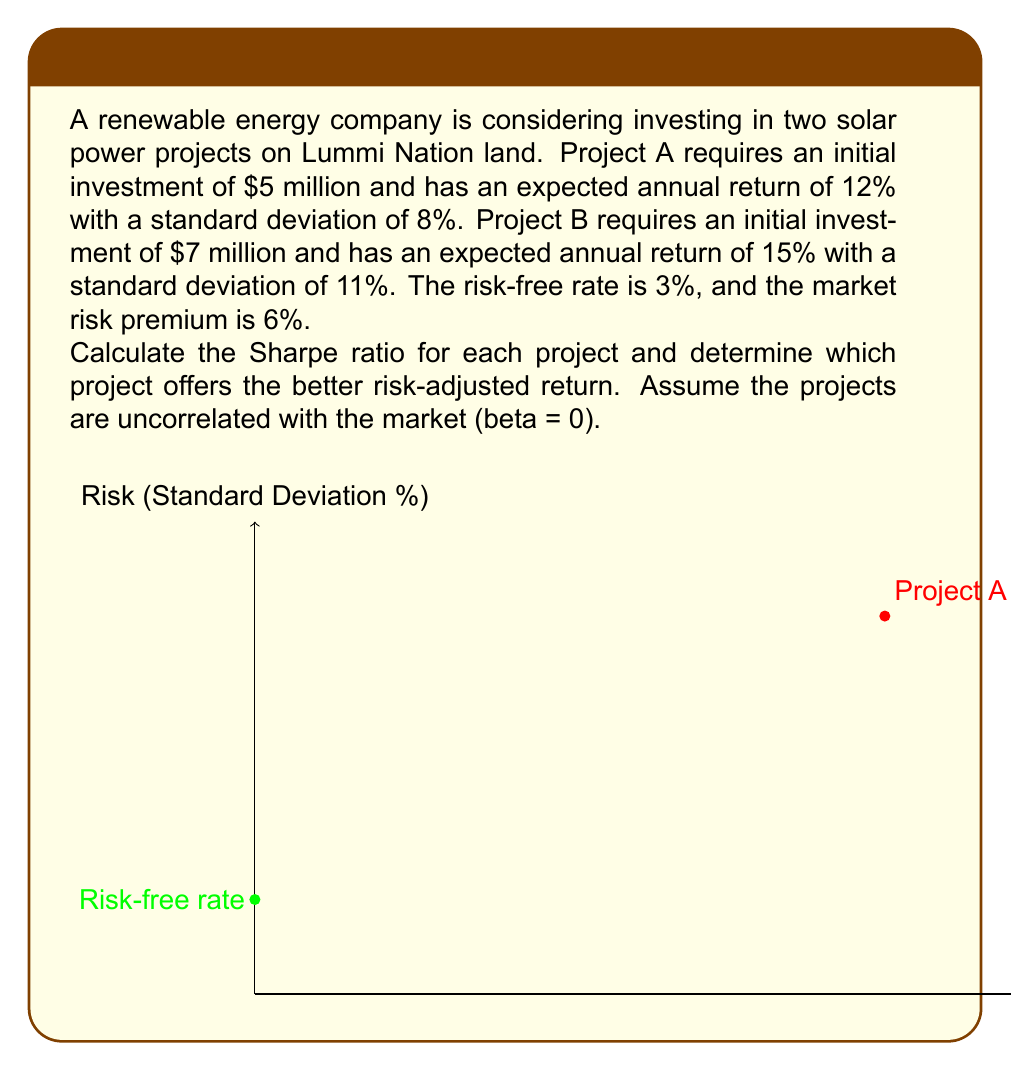Can you answer this question? To solve this problem, we'll follow these steps:

1) First, recall the formula for the Sharpe ratio:

   $$ \text{Sharpe Ratio} = \frac{R_p - R_f}{\sigma_p} $$

   Where:
   $R_p$ = Expected return of the project
   $R_f$ = Risk-free rate
   $\sigma_p$ = Standard deviation of the project's returns

2) For Project A:
   $R_p = 12\%$
   $R_f = 3\%$
   $\sigma_p = 8\%$

   Sharpe Ratio for Project A:
   $$ \text{Sharpe Ratio}_A = \frac{12\% - 3\%}{8\%} = \frac{9\%}{8\%} = 1.125 $$

3) For Project B:
   $R_p = 15\%$
   $R_f = 3\%$
   $\sigma_p = 11\%$

   Sharpe Ratio for Project B:
   $$ \text{Sharpe Ratio}_B = \frac{15\% - 3\%}{11\%} = \frac{12\%}{11\%} \approx 1.091 $$

4) Comparing the Sharpe ratios:
   Project A: 1.125
   Project B: 1.091

5) The project with the higher Sharpe ratio offers a better risk-adjusted return. In this case, Project A has a higher Sharpe ratio, despite having a lower expected return. This is because it also has lower risk (standard deviation), which more than compensates for the lower return in terms of risk-adjusted performance.

Note: The beta and market risk premium were not needed for this calculation, as we're using the Sharpe ratio which only considers total risk (standard deviation) rather than systematic risk (beta).
Answer: Project A offers the better risk-adjusted return with a Sharpe ratio of 1.125 compared to Project B's 1.091. 